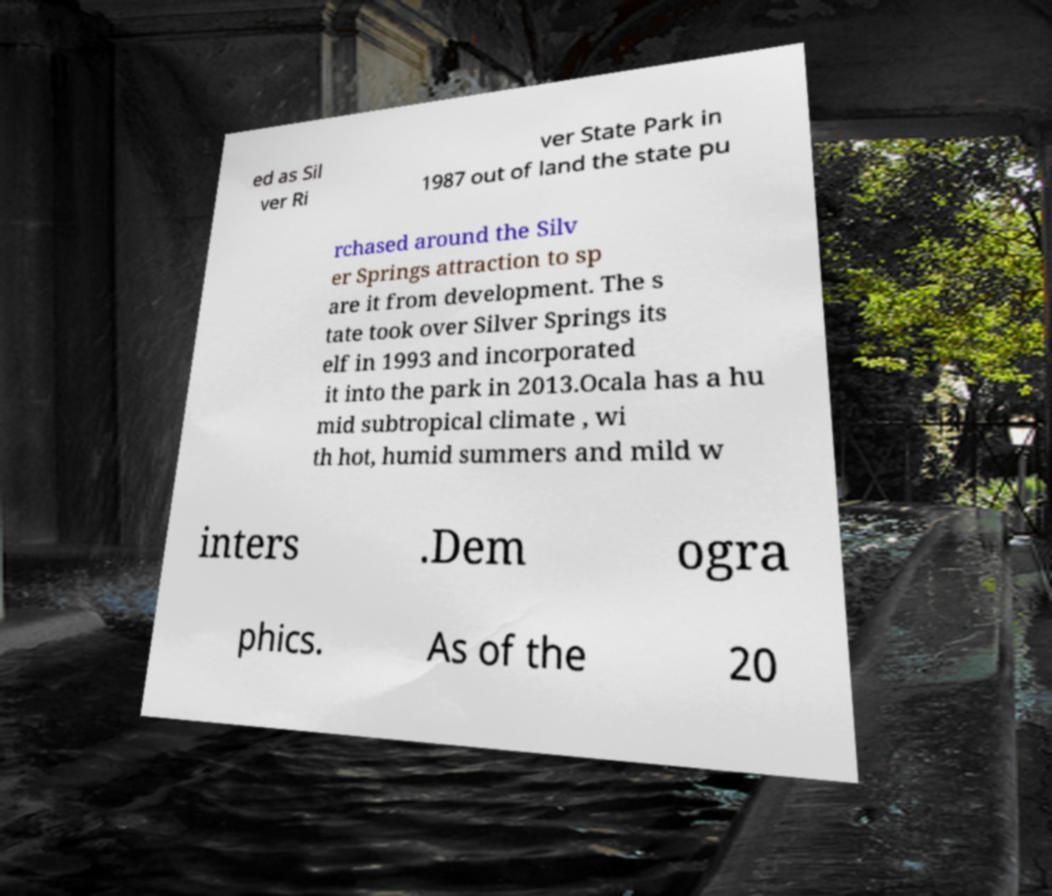Please read and relay the text visible in this image. What does it say? ed as Sil ver Ri ver State Park in 1987 out of land the state pu rchased around the Silv er Springs attraction to sp are it from development. The s tate took over Silver Springs its elf in 1993 and incorporated it into the park in 2013.Ocala has a hu mid subtropical climate , wi th hot, humid summers and mild w inters .Dem ogra phics. As of the 20 